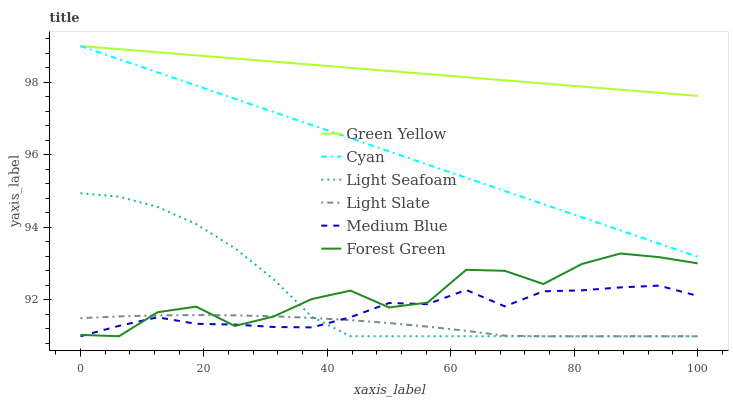Does Light Slate have the minimum area under the curve?
Answer yes or no. Yes. Does Green Yellow have the maximum area under the curve?
Answer yes or no. Yes. Does Medium Blue have the minimum area under the curve?
Answer yes or no. No. Does Medium Blue have the maximum area under the curve?
Answer yes or no. No. Is Green Yellow the smoothest?
Answer yes or no. Yes. Is Forest Green the roughest?
Answer yes or no. Yes. Is Light Slate the smoothest?
Answer yes or no. No. Is Light Slate the roughest?
Answer yes or no. No. Does Light Seafoam have the lowest value?
Answer yes or no. Yes. Does Cyan have the lowest value?
Answer yes or no. No. Does Green Yellow have the highest value?
Answer yes or no. Yes. Does Medium Blue have the highest value?
Answer yes or no. No. Is Light Seafoam less than Green Yellow?
Answer yes or no. Yes. Is Green Yellow greater than Forest Green?
Answer yes or no. Yes. Does Forest Green intersect Light Seafoam?
Answer yes or no. Yes. Is Forest Green less than Light Seafoam?
Answer yes or no. No. Is Forest Green greater than Light Seafoam?
Answer yes or no. No. Does Light Seafoam intersect Green Yellow?
Answer yes or no. No. 